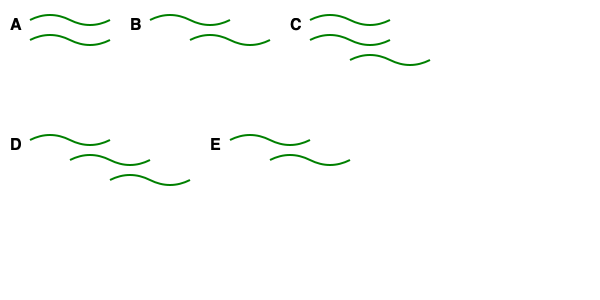As an expert in botanical illustration, identify the leaf arrangement pattern that represents "alternate phyllotaxy" from the given illustrations (A-E). To identify the correct leaf arrangement pattern for alternate phyllotaxy, let's analyze each illustration:

1. Pattern A: Shows leaves arranged in pairs at the same level on opposite sides of the stem. This represents opposite leaf arrangement, not alternate.

2. Pattern B: Displays leaves emerging from different points along the stem, with each leaf at a different level. This is the characteristic of alternate phyllotaxy.

3. Pattern C: Illustrates three leaves emerging from the same point on the stem, forming a whorl. This represents whorled leaf arrangement, not alternate.

4. Pattern D: Shows leaves arranged in a spiral pattern along the stem, with each leaf emerging at a different level and angle. While this is a form of alternate arrangement, it specifically represents spiral phyllotaxy, a subset of alternate arrangement.

5. Pattern E: Depicts leaves arranged in pairs, but at different levels along the stem. This represents decussate leaf arrangement, a variation of opposite arrangement, not alternate.

Alternate phyllotaxy is characterized by leaves emerging singly at different points along the stem, with each leaf at a different level. This description best matches Pattern B in the given illustrations.
Answer: B 